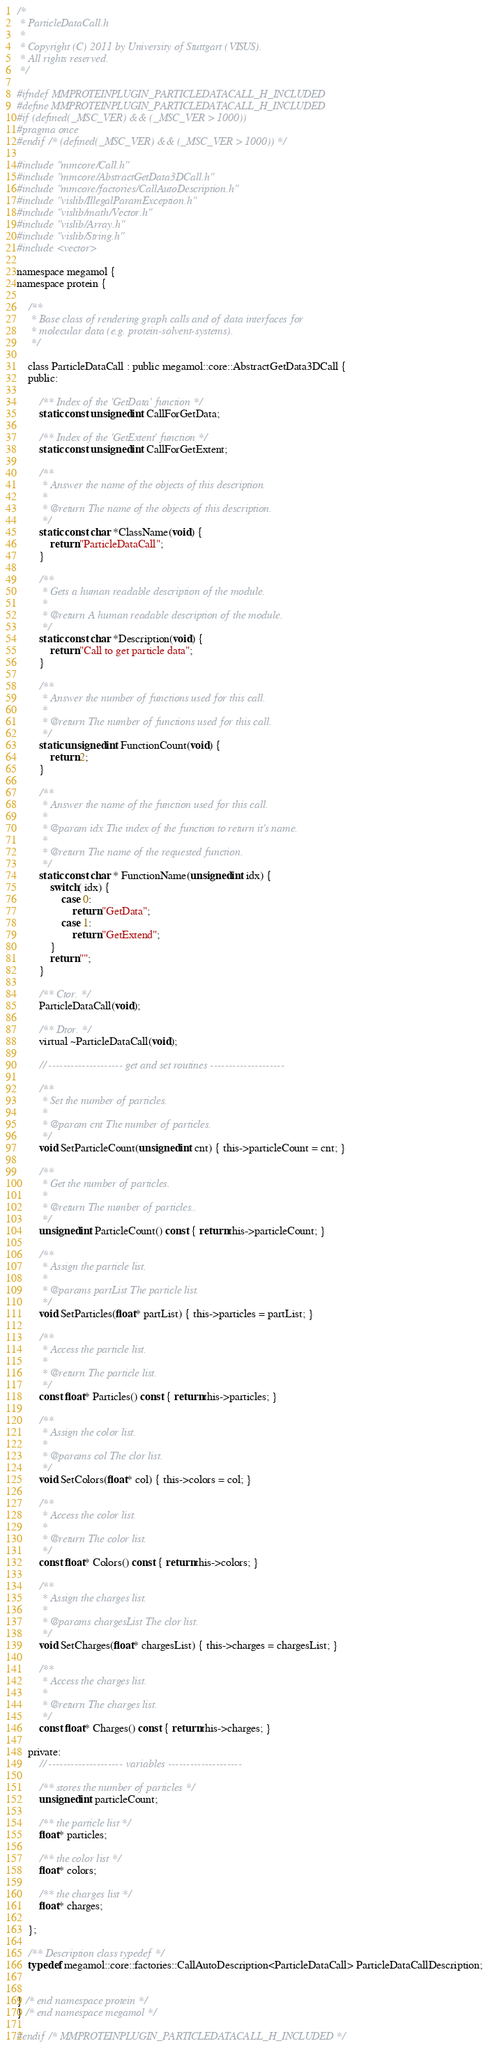<code> <loc_0><loc_0><loc_500><loc_500><_C_>/*
 * ParticleDataCall.h
 *
 * Copyright (C) 2011 by University of Stuttgart (VISUS).
 * All rights reserved.
 */

#ifndef MMPROTEINPLUGIN_PARTICLEDATACALL_H_INCLUDED
#define MMPROTEINPLUGIN_PARTICLEDATACALL_H_INCLUDED
#if (defined(_MSC_VER) && (_MSC_VER > 1000))
#pragma once
#endif /* (defined(_MSC_VER) && (_MSC_VER > 1000)) */

#include "mmcore/Call.h"
#include "mmcore/AbstractGetData3DCall.h"
#include "mmcore/factories/CallAutoDescription.h"
#include "vislib/IllegalParamException.h"
#include "vislib/math/Vector.h"
#include "vislib/Array.h"
#include "vislib/String.h"
#include <vector>

namespace megamol {
namespace protein {

    /**
     * Base class of rendering graph calls and of data interfaces for 
     * molecular data (e.g. protein-solvent-systems).
     */

    class ParticleDataCall : public megamol::core::AbstractGetData3DCall {
    public:

        /** Index of the 'GetData' function */
        static const unsigned int CallForGetData;

        /** Index of the 'GetExtent' function */
        static const unsigned int CallForGetExtent;

        /**
         * Answer the name of the objects of this description.
         *
         * @return The name of the objects of this description.
         */
        static const char *ClassName(void) {
            return "ParticleDataCall";
        }

        /**
         * Gets a human readable description of the module.
         *
         * @return A human readable description of the module.
         */
        static const char *Description(void) {
            return "Call to get particle data";
        }

        /**
         * Answer the number of functions used for this call.
         *
         * @return The number of functions used for this call.
         */
        static unsigned int FunctionCount(void) {
            return 2;
        }

        /**
         * Answer the name of the function used for this call.
         *
         * @param idx The index of the function to return it's name.
         *
         * @return The name of the requested function.
         */
        static const char * FunctionName(unsigned int idx) {
            switch( idx) {
                case 0:
                    return "GetData";
                case 1:
                    return "GetExtend";
            }
			return "";
        }

        /** Ctor. */
        ParticleDataCall(void);

        /** Dtor. */
        virtual ~ParticleDataCall(void);

        // -------------------- get and set routines --------------------

        /**
         * Set the number of particles.
         *
         * @param cnt The number of particles.
         */
        void SetParticleCount(unsigned int cnt) { this->particleCount = cnt; }

        /**
         * Get the number of particles.
         *
         * @return The number of particles..
         */
        unsigned int ParticleCount() const { return this->particleCount; }

        /**
         * Assign the particle list.
         *
         * @params partList The particle list.
         */
        void SetParticles(float* partList) { this->particles = partList; }

        /**
         * Access the particle list.
         *
         * @return The particle list.
         */
        const float* Particles() const { return this->particles; }

        /**
         * Assign the color list.
         *
         * @params col The clor list.
         */
        void SetColors(float* col) { this->colors = col; }

        /**
         * Access the color list.
         *
         * @return The color list.
         */
        const float* Colors() const { return this->colors; }

        /**
         * Assign the charges list.
         *
         * @params chargesList The clor list.
         */
        void SetCharges(float* chargesList) { this->charges = chargesList; }

        /**
         * Access the charges list.
         *
         * @return The charges list.
         */
        const float* Charges() const { return this->charges; }

    private:
        // -------------------- variables --------------------

        /** stores the number of particles */
        unsigned int particleCount;

        /** the particle list */
        float* particles;

        /** the color list */
        float* colors;

        /** the charges list */
        float* charges;

    };

    /** Description class typedef */
    typedef megamol::core::factories::CallAutoDescription<ParticleDataCall> ParticleDataCallDescription;


} /* end namespace protein */
} /* end namespace megamol */

#endif /* MMPROTEINPLUGIN_PARTICLEDATACALL_H_INCLUDED */
</code> 